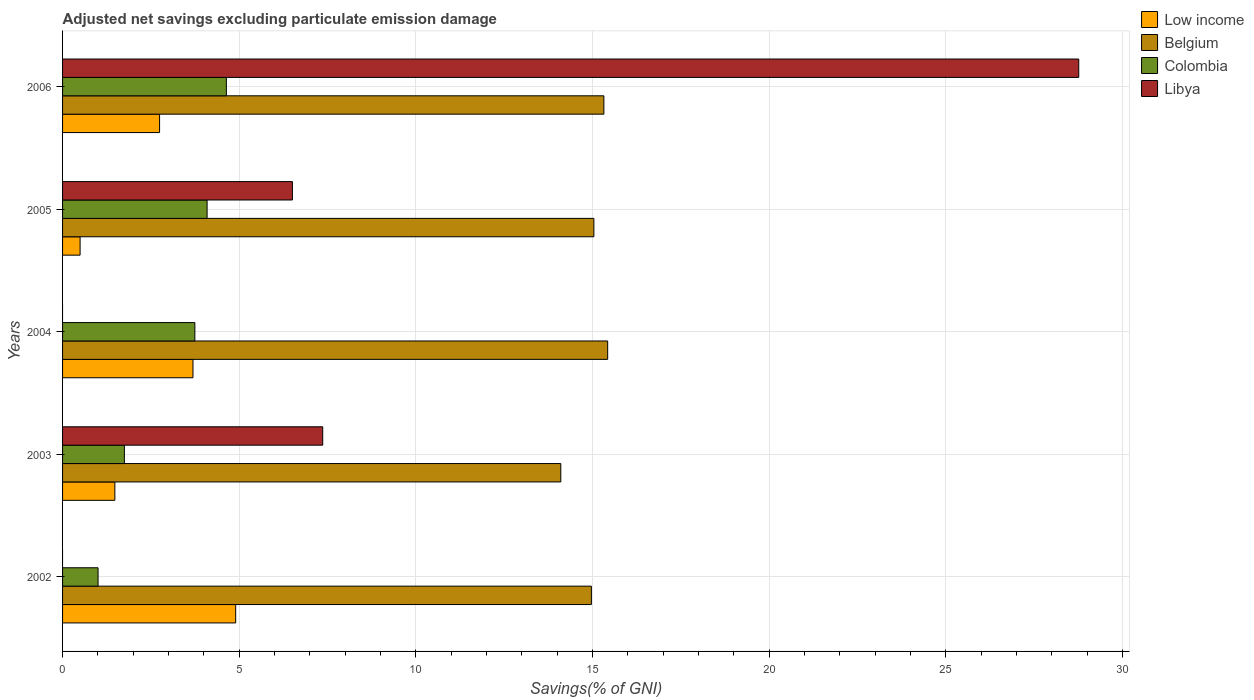How many different coloured bars are there?
Give a very brief answer. 4. In how many cases, is the number of bars for a given year not equal to the number of legend labels?
Provide a short and direct response. 2. What is the adjusted net savings in Libya in 2006?
Offer a very short reply. 28.76. Across all years, what is the maximum adjusted net savings in Low income?
Make the answer very short. 4.9. Across all years, what is the minimum adjusted net savings in Low income?
Keep it short and to the point. 0.5. In which year was the adjusted net savings in Colombia maximum?
Give a very brief answer. 2006. What is the total adjusted net savings in Low income in the graph?
Provide a succinct answer. 13.31. What is the difference between the adjusted net savings in Belgium in 2002 and that in 2003?
Your answer should be compact. 0.87. What is the difference between the adjusted net savings in Belgium in 2006 and the adjusted net savings in Colombia in 2003?
Give a very brief answer. 13.57. What is the average adjusted net savings in Belgium per year?
Make the answer very short. 14.97. In the year 2005, what is the difference between the adjusted net savings in Colombia and adjusted net savings in Libya?
Your response must be concise. -2.41. In how many years, is the adjusted net savings in Belgium greater than 14 %?
Offer a terse response. 5. What is the ratio of the adjusted net savings in Libya in 2005 to that in 2006?
Make the answer very short. 0.23. Is the difference between the adjusted net savings in Colombia in 2003 and 2005 greater than the difference between the adjusted net savings in Libya in 2003 and 2005?
Offer a very short reply. No. What is the difference between the highest and the second highest adjusted net savings in Belgium?
Offer a terse response. 0.11. What is the difference between the highest and the lowest adjusted net savings in Libya?
Your answer should be compact. 28.76. In how many years, is the adjusted net savings in Belgium greater than the average adjusted net savings in Belgium taken over all years?
Make the answer very short. 3. Is the sum of the adjusted net savings in Libya in 2003 and 2006 greater than the maximum adjusted net savings in Colombia across all years?
Give a very brief answer. Yes. Is it the case that in every year, the sum of the adjusted net savings in Colombia and adjusted net savings in Libya is greater than the sum of adjusted net savings in Belgium and adjusted net savings in Low income?
Keep it short and to the point. No. Are all the bars in the graph horizontal?
Make the answer very short. Yes. How many years are there in the graph?
Keep it short and to the point. 5. What is the difference between two consecutive major ticks on the X-axis?
Your response must be concise. 5. Does the graph contain grids?
Your answer should be compact. Yes. Where does the legend appear in the graph?
Give a very brief answer. Top right. How many legend labels are there?
Your answer should be very brief. 4. What is the title of the graph?
Make the answer very short. Adjusted net savings excluding particulate emission damage. Does "Solomon Islands" appear as one of the legend labels in the graph?
Your answer should be very brief. No. What is the label or title of the X-axis?
Offer a very short reply. Savings(% of GNI). What is the label or title of the Y-axis?
Ensure brevity in your answer.  Years. What is the Savings(% of GNI) in Low income in 2002?
Provide a succinct answer. 4.9. What is the Savings(% of GNI) in Belgium in 2002?
Offer a terse response. 14.97. What is the Savings(% of GNI) of Colombia in 2002?
Offer a very short reply. 1. What is the Savings(% of GNI) of Low income in 2003?
Offer a very short reply. 1.48. What is the Savings(% of GNI) in Belgium in 2003?
Give a very brief answer. 14.1. What is the Savings(% of GNI) of Colombia in 2003?
Give a very brief answer. 1.75. What is the Savings(% of GNI) in Libya in 2003?
Give a very brief answer. 7.36. What is the Savings(% of GNI) of Low income in 2004?
Make the answer very short. 3.69. What is the Savings(% of GNI) of Belgium in 2004?
Give a very brief answer. 15.43. What is the Savings(% of GNI) of Colombia in 2004?
Provide a succinct answer. 3.74. What is the Savings(% of GNI) of Low income in 2005?
Your answer should be compact. 0.5. What is the Savings(% of GNI) in Belgium in 2005?
Offer a very short reply. 15.04. What is the Savings(% of GNI) of Colombia in 2005?
Your answer should be very brief. 4.09. What is the Savings(% of GNI) of Libya in 2005?
Ensure brevity in your answer.  6.51. What is the Savings(% of GNI) in Low income in 2006?
Make the answer very short. 2.75. What is the Savings(% of GNI) of Belgium in 2006?
Give a very brief answer. 15.32. What is the Savings(% of GNI) in Colombia in 2006?
Your answer should be compact. 4.64. What is the Savings(% of GNI) of Libya in 2006?
Offer a very short reply. 28.76. Across all years, what is the maximum Savings(% of GNI) of Low income?
Give a very brief answer. 4.9. Across all years, what is the maximum Savings(% of GNI) of Belgium?
Make the answer very short. 15.43. Across all years, what is the maximum Savings(% of GNI) in Colombia?
Your answer should be very brief. 4.64. Across all years, what is the maximum Savings(% of GNI) of Libya?
Your answer should be compact. 28.76. Across all years, what is the minimum Savings(% of GNI) of Low income?
Provide a short and direct response. 0.5. Across all years, what is the minimum Savings(% of GNI) in Belgium?
Ensure brevity in your answer.  14.1. Across all years, what is the minimum Savings(% of GNI) of Colombia?
Your answer should be very brief. 1. What is the total Savings(% of GNI) of Low income in the graph?
Provide a succinct answer. 13.31. What is the total Savings(% of GNI) in Belgium in the graph?
Offer a terse response. 74.85. What is the total Savings(% of GNI) in Colombia in the graph?
Your answer should be very brief. 15.22. What is the total Savings(% of GNI) of Libya in the graph?
Ensure brevity in your answer.  42.63. What is the difference between the Savings(% of GNI) of Low income in 2002 and that in 2003?
Your answer should be very brief. 3.42. What is the difference between the Savings(% of GNI) of Belgium in 2002 and that in 2003?
Ensure brevity in your answer.  0.87. What is the difference between the Savings(% of GNI) in Colombia in 2002 and that in 2003?
Ensure brevity in your answer.  -0.74. What is the difference between the Savings(% of GNI) in Low income in 2002 and that in 2004?
Give a very brief answer. 1.21. What is the difference between the Savings(% of GNI) of Belgium in 2002 and that in 2004?
Provide a succinct answer. -0.46. What is the difference between the Savings(% of GNI) in Colombia in 2002 and that in 2004?
Provide a short and direct response. -2.74. What is the difference between the Savings(% of GNI) of Low income in 2002 and that in 2005?
Your answer should be very brief. 4.4. What is the difference between the Savings(% of GNI) in Belgium in 2002 and that in 2005?
Offer a very short reply. -0.07. What is the difference between the Savings(% of GNI) in Colombia in 2002 and that in 2005?
Your answer should be compact. -3.09. What is the difference between the Savings(% of GNI) in Low income in 2002 and that in 2006?
Provide a short and direct response. 2.15. What is the difference between the Savings(% of GNI) in Belgium in 2002 and that in 2006?
Offer a terse response. -0.35. What is the difference between the Savings(% of GNI) in Colombia in 2002 and that in 2006?
Ensure brevity in your answer.  -3.63. What is the difference between the Savings(% of GNI) in Low income in 2003 and that in 2004?
Provide a succinct answer. -2.21. What is the difference between the Savings(% of GNI) in Belgium in 2003 and that in 2004?
Make the answer very short. -1.33. What is the difference between the Savings(% of GNI) of Colombia in 2003 and that in 2004?
Provide a succinct answer. -2. What is the difference between the Savings(% of GNI) in Low income in 2003 and that in 2005?
Ensure brevity in your answer.  0.98. What is the difference between the Savings(% of GNI) of Belgium in 2003 and that in 2005?
Your response must be concise. -0.94. What is the difference between the Savings(% of GNI) in Colombia in 2003 and that in 2005?
Your response must be concise. -2.34. What is the difference between the Savings(% of GNI) of Libya in 2003 and that in 2005?
Give a very brief answer. 0.86. What is the difference between the Savings(% of GNI) of Low income in 2003 and that in 2006?
Give a very brief answer. -1.27. What is the difference between the Savings(% of GNI) in Belgium in 2003 and that in 2006?
Your answer should be compact. -1.22. What is the difference between the Savings(% of GNI) of Colombia in 2003 and that in 2006?
Give a very brief answer. -2.89. What is the difference between the Savings(% of GNI) of Libya in 2003 and that in 2006?
Make the answer very short. -21.4. What is the difference between the Savings(% of GNI) in Low income in 2004 and that in 2005?
Your answer should be very brief. 3.19. What is the difference between the Savings(% of GNI) of Belgium in 2004 and that in 2005?
Your answer should be compact. 0.39. What is the difference between the Savings(% of GNI) in Colombia in 2004 and that in 2005?
Offer a very short reply. -0.35. What is the difference between the Savings(% of GNI) in Low income in 2004 and that in 2006?
Give a very brief answer. 0.95. What is the difference between the Savings(% of GNI) of Belgium in 2004 and that in 2006?
Your answer should be compact. 0.11. What is the difference between the Savings(% of GNI) in Colombia in 2004 and that in 2006?
Keep it short and to the point. -0.89. What is the difference between the Savings(% of GNI) in Low income in 2005 and that in 2006?
Make the answer very short. -2.25. What is the difference between the Savings(% of GNI) in Belgium in 2005 and that in 2006?
Keep it short and to the point. -0.28. What is the difference between the Savings(% of GNI) of Colombia in 2005 and that in 2006?
Provide a succinct answer. -0.55. What is the difference between the Savings(% of GNI) of Libya in 2005 and that in 2006?
Provide a succinct answer. -22.25. What is the difference between the Savings(% of GNI) of Low income in 2002 and the Savings(% of GNI) of Belgium in 2003?
Offer a very short reply. -9.2. What is the difference between the Savings(% of GNI) of Low income in 2002 and the Savings(% of GNI) of Colombia in 2003?
Offer a very short reply. 3.15. What is the difference between the Savings(% of GNI) in Low income in 2002 and the Savings(% of GNI) in Libya in 2003?
Offer a very short reply. -2.46. What is the difference between the Savings(% of GNI) in Belgium in 2002 and the Savings(% of GNI) in Colombia in 2003?
Offer a terse response. 13.22. What is the difference between the Savings(% of GNI) in Belgium in 2002 and the Savings(% of GNI) in Libya in 2003?
Your answer should be compact. 7.6. What is the difference between the Savings(% of GNI) in Colombia in 2002 and the Savings(% of GNI) in Libya in 2003?
Your answer should be very brief. -6.36. What is the difference between the Savings(% of GNI) of Low income in 2002 and the Savings(% of GNI) of Belgium in 2004?
Provide a short and direct response. -10.53. What is the difference between the Savings(% of GNI) in Low income in 2002 and the Savings(% of GNI) in Colombia in 2004?
Your answer should be very brief. 1.16. What is the difference between the Savings(% of GNI) of Belgium in 2002 and the Savings(% of GNI) of Colombia in 2004?
Your answer should be very brief. 11.22. What is the difference between the Savings(% of GNI) in Low income in 2002 and the Savings(% of GNI) in Belgium in 2005?
Give a very brief answer. -10.14. What is the difference between the Savings(% of GNI) of Low income in 2002 and the Savings(% of GNI) of Colombia in 2005?
Keep it short and to the point. 0.81. What is the difference between the Savings(% of GNI) of Low income in 2002 and the Savings(% of GNI) of Libya in 2005?
Offer a very short reply. -1.61. What is the difference between the Savings(% of GNI) of Belgium in 2002 and the Savings(% of GNI) of Colombia in 2005?
Your response must be concise. 10.88. What is the difference between the Savings(% of GNI) in Belgium in 2002 and the Savings(% of GNI) in Libya in 2005?
Offer a very short reply. 8.46. What is the difference between the Savings(% of GNI) of Colombia in 2002 and the Savings(% of GNI) of Libya in 2005?
Offer a very short reply. -5.5. What is the difference between the Savings(% of GNI) of Low income in 2002 and the Savings(% of GNI) of Belgium in 2006?
Your response must be concise. -10.42. What is the difference between the Savings(% of GNI) of Low income in 2002 and the Savings(% of GNI) of Colombia in 2006?
Your answer should be compact. 0.26. What is the difference between the Savings(% of GNI) in Low income in 2002 and the Savings(% of GNI) in Libya in 2006?
Your answer should be compact. -23.86. What is the difference between the Savings(% of GNI) of Belgium in 2002 and the Savings(% of GNI) of Colombia in 2006?
Ensure brevity in your answer.  10.33. What is the difference between the Savings(% of GNI) in Belgium in 2002 and the Savings(% of GNI) in Libya in 2006?
Provide a succinct answer. -13.79. What is the difference between the Savings(% of GNI) in Colombia in 2002 and the Savings(% of GNI) in Libya in 2006?
Make the answer very short. -27.76. What is the difference between the Savings(% of GNI) of Low income in 2003 and the Savings(% of GNI) of Belgium in 2004?
Offer a very short reply. -13.95. What is the difference between the Savings(% of GNI) in Low income in 2003 and the Savings(% of GNI) in Colombia in 2004?
Your answer should be very brief. -2.26. What is the difference between the Savings(% of GNI) in Belgium in 2003 and the Savings(% of GNI) in Colombia in 2004?
Give a very brief answer. 10.36. What is the difference between the Savings(% of GNI) in Low income in 2003 and the Savings(% of GNI) in Belgium in 2005?
Your answer should be very brief. -13.56. What is the difference between the Savings(% of GNI) in Low income in 2003 and the Savings(% of GNI) in Colombia in 2005?
Offer a terse response. -2.61. What is the difference between the Savings(% of GNI) of Low income in 2003 and the Savings(% of GNI) of Libya in 2005?
Ensure brevity in your answer.  -5.03. What is the difference between the Savings(% of GNI) of Belgium in 2003 and the Savings(% of GNI) of Colombia in 2005?
Your answer should be very brief. 10.01. What is the difference between the Savings(% of GNI) of Belgium in 2003 and the Savings(% of GNI) of Libya in 2005?
Your answer should be compact. 7.6. What is the difference between the Savings(% of GNI) in Colombia in 2003 and the Savings(% of GNI) in Libya in 2005?
Give a very brief answer. -4.76. What is the difference between the Savings(% of GNI) of Low income in 2003 and the Savings(% of GNI) of Belgium in 2006?
Provide a short and direct response. -13.84. What is the difference between the Savings(% of GNI) in Low income in 2003 and the Savings(% of GNI) in Colombia in 2006?
Ensure brevity in your answer.  -3.16. What is the difference between the Savings(% of GNI) of Low income in 2003 and the Savings(% of GNI) of Libya in 2006?
Your answer should be compact. -27.28. What is the difference between the Savings(% of GNI) in Belgium in 2003 and the Savings(% of GNI) in Colombia in 2006?
Your response must be concise. 9.47. What is the difference between the Savings(% of GNI) in Belgium in 2003 and the Savings(% of GNI) in Libya in 2006?
Provide a short and direct response. -14.66. What is the difference between the Savings(% of GNI) of Colombia in 2003 and the Savings(% of GNI) of Libya in 2006?
Your answer should be compact. -27.01. What is the difference between the Savings(% of GNI) in Low income in 2004 and the Savings(% of GNI) in Belgium in 2005?
Your answer should be compact. -11.35. What is the difference between the Savings(% of GNI) of Low income in 2004 and the Savings(% of GNI) of Colombia in 2005?
Give a very brief answer. -0.4. What is the difference between the Savings(% of GNI) of Low income in 2004 and the Savings(% of GNI) of Libya in 2005?
Offer a terse response. -2.81. What is the difference between the Savings(% of GNI) in Belgium in 2004 and the Savings(% of GNI) in Colombia in 2005?
Provide a succinct answer. 11.34. What is the difference between the Savings(% of GNI) of Belgium in 2004 and the Savings(% of GNI) of Libya in 2005?
Offer a very short reply. 8.92. What is the difference between the Savings(% of GNI) of Colombia in 2004 and the Savings(% of GNI) of Libya in 2005?
Make the answer very short. -2.76. What is the difference between the Savings(% of GNI) in Low income in 2004 and the Savings(% of GNI) in Belgium in 2006?
Your answer should be very brief. -11.63. What is the difference between the Savings(% of GNI) in Low income in 2004 and the Savings(% of GNI) in Colombia in 2006?
Provide a succinct answer. -0.94. What is the difference between the Savings(% of GNI) in Low income in 2004 and the Savings(% of GNI) in Libya in 2006?
Provide a succinct answer. -25.07. What is the difference between the Savings(% of GNI) in Belgium in 2004 and the Savings(% of GNI) in Colombia in 2006?
Give a very brief answer. 10.79. What is the difference between the Savings(% of GNI) in Belgium in 2004 and the Savings(% of GNI) in Libya in 2006?
Ensure brevity in your answer.  -13.33. What is the difference between the Savings(% of GNI) of Colombia in 2004 and the Savings(% of GNI) of Libya in 2006?
Provide a succinct answer. -25.02. What is the difference between the Savings(% of GNI) in Low income in 2005 and the Savings(% of GNI) in Belgium in 2006?
Give a very brief answer. -14.82. What is the difference between the Savings(% of GNI) of Low income in 2005 and the Savings(% of GNI) of Colombia in 2006?
Your answer should be compact. -4.14. What is the difference between the Savings(% of GNI) of Low income in 2005 and the Savings(% of GNI) of Libya in 2006?
Your answer should be compact. -28.26. What is the difference between the Savings(% of GNI) in Belgium in 2005 and the Savings(% of GNI) in Colombia in 2006?
Ensure brevity in your answer.  10.4. What is the difference between the Savings(% of GNI) in Belgium in 2005 and the Savings(% of GNI) in Libya in 2006?
Provide a short and direct response. -13.72. What is the difference between the Savings(% of GNI) of Colombia in 2005 and the Savings(% of GNI) of Libya in 2006?
Your answer should be very brief. -24.67. What is the average Savings(% of GNI) of Low income per year?
Your answer should be compact. 2.66. What is the average Savings(% of GNI) in Belgium per year?
Provide a succinct answer. 14.97. What is the average Savings(% of GNI) in Colombia per year?
Offer a terse response. 3.04. What is the average Savings(% of GNI) in Libya per year?
Give a very brief answer. 8.53. In the year 2002, what is the difference between the Savings(% of GNI) of Low income and Savings(% of GNI) of Belgium?
Your answer should be compact. -10.07. In the year 2002, what is the difference between the Savings(% of GNI) in Low income and Savings(% of GNI) in Colombia?
Your response must be concise. 3.89. In the year 2002, what is the difference between the Savings(% of GNI) of Belgium and Savings(% of GNI) of Colombia?
Your answer should be compact. 13.96. In the year 2003, what is the difference between the Savings(% of GNI) of Low income and Savings(% of GNI) of Belgium?
Offer a very short reply. -12.62. In the year 2003, what is the difference between the Savings(% of GNI) in Low income and Savings(% of GNI) in Colombia?
Provide a short and direct response. -0.27. In the year 2003, what is the difference between the Savings(% of GNI) in Low income and Savings(% of GNI) in Libya?
Offer a very short reply. -5.88. In the year 2003, what is the difference between the Savings(% of GNI) in Belgium and Savings(% of GNI) in Colombia?
Your response must be concise. 12.35. In the year 2003, what is the difference between the Savings(% of GNI) of Belgium and Savings(% of GNI) of Libya?
Your response must be concise. 6.74. In the year 2003, what is the difference between the Savings(% of GNI) in Colombia and Savings(% of GNI) in Libya?
Offer a terse response. -5.61. In the year 2004, what is the difference between the Savings(% of GNI) in Low income and Savings(% of GNI) in Belgium?
Give a very brief answer. -11.74. In the year 2004, what is the difference between the Savings(% of GNI) of Low income and Savings(% of GNI) of Colombia?
Make the answer very short. -0.05. In the year 2004, what is the difference between the Savings(% of GNI) of Belgium and Savings(% of GNI) of Colombia?
Offer a terse response. 11.68. In the year 2005, what is the difference between the Savings(% of GNI) of Low income and Savings(% of GNI) of Belgium?
Your response must be concise. -14.54. In the year 2005, what is the difference between the Savings(% of GNI) in Low income and Savings(% of GNI) in Colombia?
Make the answer very short. -3.59. In the year 2005, what is the difference between the Savings(% of GNI) in Low income and Savings(% of GNI) in Libya?
Ensure brevity in your answer.  -6.01. In the year 2005, what is the difference between the Savings(% of GNI) of Belgium and Savings(% of GNI) of Colombia?
Keep it short and to the point. 10.95. In the year 2005, what is the difference between the Savings(% of GNI) in Belgium and Savings(% of GNI) in Libya?
Keep it short and to the point. 8.53. In the year 2005, what is the difference between the Savings(% of GNI) in Colombia and Savings(% of GNI) in Libya?
Your answer should be very brief. -2.41. In the year 2006, what is the difference between the Savings(% of GNI) of Low income and Savings(% of GNI) of Belgium?
Make the answer very short. -12.57. In the year 2006, what is the difference between the Savings(% of GNI) in Low income and Savings(% of GNI) in Colombia?
Ensure brevity in your answer.  -1.89. In the year 2006, what is the difference between the Savings(% of GNI) in Low income and Savings(% of GNI) in Libya?
Your answer should be compact. -26.01. In the year 2006, what is the difference between the Savings(% of GNI) of Belgium and Savings(% of GNI) of Colombia?
Keep it short and to the point. 10.68. In the year 2006, what is the difference between the Savings(% of GNI) in Belgium and Savings(% of GNI) in Libya?
Your answer should be compact. -13.44. In the year 2006, what is the difference between the Savings(% of GNI) in Colombia and Savings(% of GNI) in Libya?
Keep it short and to the point. -24.12. What is the ratio of the Savings(% of GNI) of Low income in 2002 to that in 2003?
Your response must be concise. 3.31. What is the ratio of the Savings(% of GNI) of Belgium in 2002 to that in 2003?
Give a very brief answer. 1.06. What is the ratio of the Savings(% of GNI) of Colombia in 2002 to that in 2003?
Provide a short and direct response. 0.57. What is the ratio of the Savings(% of GNI) of Low income in 2002 to that in 2004?
Your answer should be compact. 1.33. What is the ratio of the Savings(% of GNI) of Belgium in 2002 to that in 2004?
Your answer should be very brief. 0.97. What is the ratio of the Savings(% of GNI) in Colombia in 2002 to that in 2004?
Offer a terse response. 0.27. What is the ratio of the Savings(% of GNI) of Low income in 2002 to that in 2005?
Ensure brevity in your answer.  9.88. What is the ratio of the Savings(% of GNI) of Belgium in 2002 to that in 2005?
Your answer should be very brief. 1. What is the ratio of the Savings(% of GNI) of Colombia in 2002 to that in 2005?
Provide a succinct answer. 0.25. What is the ratio of the Savings(% of GNI) in Low income in 2002 to that in 2006?
Give a very brief answer. 1.78. What is the ratio of the Savings(% of GNI) of Belgium in 2002 to that in 2006?
Provide a succinct answer. 0.98. What is the ratio of the Savings(% of GNI) in Colombia in 2002 to that in 2006?
Give a very brief answer. 0.22. What is the ratio of the Savings(% of GNI) of Low income in 2003 to that in 2004?
Give a very brief answer. 0.4. What is the ratio of the Savings(% of GNI) of Belgium in 2003 to that in 2004?
Offer a terse response. 0.91. What is the ratio of the Savings(% of GNI) of Colombia in 2003 to that in 2004?
Your answer should be very brief. 0.47. What is the ratio of the Savings(% of GNI) of Low income in 2003 to that in 2005?
Offer a very short reply. 2.98. What is the ratio of the Savings(% of GNI) of Belgium in 2003 to that in 2005?
Make the answer very short. 0.94. What is the ratio of the Savings(% of GNI) of Colombia in 2003 to that in 2005?
Make the answer very short. 0.43. What is the ratio of the Savings(% of GNI) of Libya in 2003 to that in 2005?
Offer a terse response. 1.13. What is the ratio of the Savings(% of GNI) of Low income in 2003 to that in 2006?
Offer a very short reply. 0.54. What is the ratio of the Savings(% of GNI) of Belgium in 2003 to that in 2006?
Give a very brief answer. 0.92. What is the ratio of the Savings(% of GNI) in Colombia in 2003 to that in 2006?
Your answer should be compact. 0.38. What is the ratio of the Savings(% of GNI) of Libya in 2003 to that in 2006?
Ensure brevity in your answer.  0.26. What is the ratio of the Savings(% of GNI) of Low income in 2004 to that in 2005?
Your response must be concise. 7.44. What is the ratio of the Savings(% of GNI) in Belgium in 2004 to that in 2005?
Your response must be concise. 1.03. What is the ratio of the Savings(% of GNI) of Colombia in 2004 to that in 2005?
Offer a very short reply. 0.92. What is the ratio of the Savings(% of GNI) of Low income in 2004 to that in 2006?
Your response must be concise. 1.34. What is the ratio of the Savings(% of GNI) of Belgium in 2004 to that in 2006?
Provide a short and direct response. 1.01. What is the ratio of the Savings(% of GNI) in Colombia in 2004 to that in 2006?
Keep it short and to the point. 0.81. What is the ratio of the Savings(% of GNI) in Low income in 2005 to that in 2006?
Make the answer very short. 0.18. What is the ratio of the Savings(% of GNI) of Belgium in 2005 to that in 2006?
Your answer should be very brief. 0.98. What is the ratio of the Savings(% of GNI) in Colombia in 2005 to that in 2006?
Your answer should be compact. 0.88. What is the ratio of the Savings(% of GNI) of Libya in 2005 to that in 2006?
Provide a succinct answer. 0.23. What is the difference between the highest and the second highest Savings(% of GNI) in Low income?
Make the answer very short. 1.21. What is the difference between the highest and the second highest Savings(% of GNI) of Belgium?
Your answer should be very brief. 0.11. What is the difference between the highest and the second highest Savings(% of GNI) of Colombia?
Your response must be concise. 0.55. What is the difference between the highest and the second highest Savings(% of GNI) in Libya?
Make the answer very short. 21.4. What is the difference between the highest and the lowest Savings(% of GNI) of Low income?
Provide a succinct answer. 4.4. What is the difference between the highest and the lowest Savings(% of GNI) in Belgium?
Make the answer very short. 1.33. What is the difference between the highest and the lowest Savings(% of GNI) in Colombia?
Make the answer very short. 3.63. What is the difference between the highest and the lowest Savings(% of GNI) of Libya?
Offer a very short reply. 28.76. 